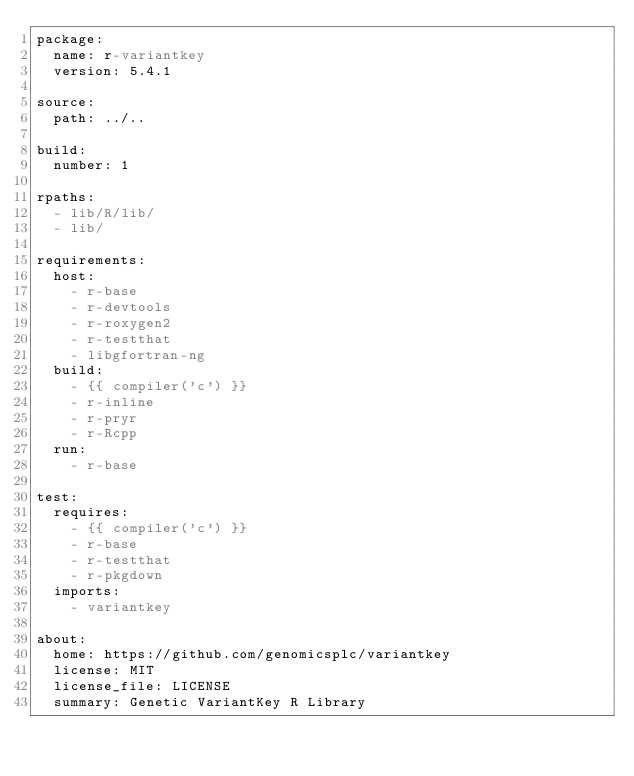Convert code to text. <code><loc_0><loc_0><loc_500><loc_500><_YAML_>package:
  name: r-variantkey
  version: 5.4.1

source:
  path: ../..

build:
  number: 1

rpaths:
  - lib/R/lib/
  - lib/

requirements:
  host:
    - r-base
    - r-devtools
    - r-roxygen2
    - r-testthat
    - libgfortran-ng
  build:
    - {{ compiler('c') }}
    - r-inline
    - r-pryr
    - r-Rcpp
  run:
    - r-base

test:
  requires:
    - {{ compiler('c') }}
    - r-base
    - r-testthat
    - r-pkgdown
  imports:
    - variantkey

about:
  home: https://github.com/genomicsplc/variantkey
  license: MIT
  license_file: LICENSE
  summary: Genetic VariantKey R Library
</code> 